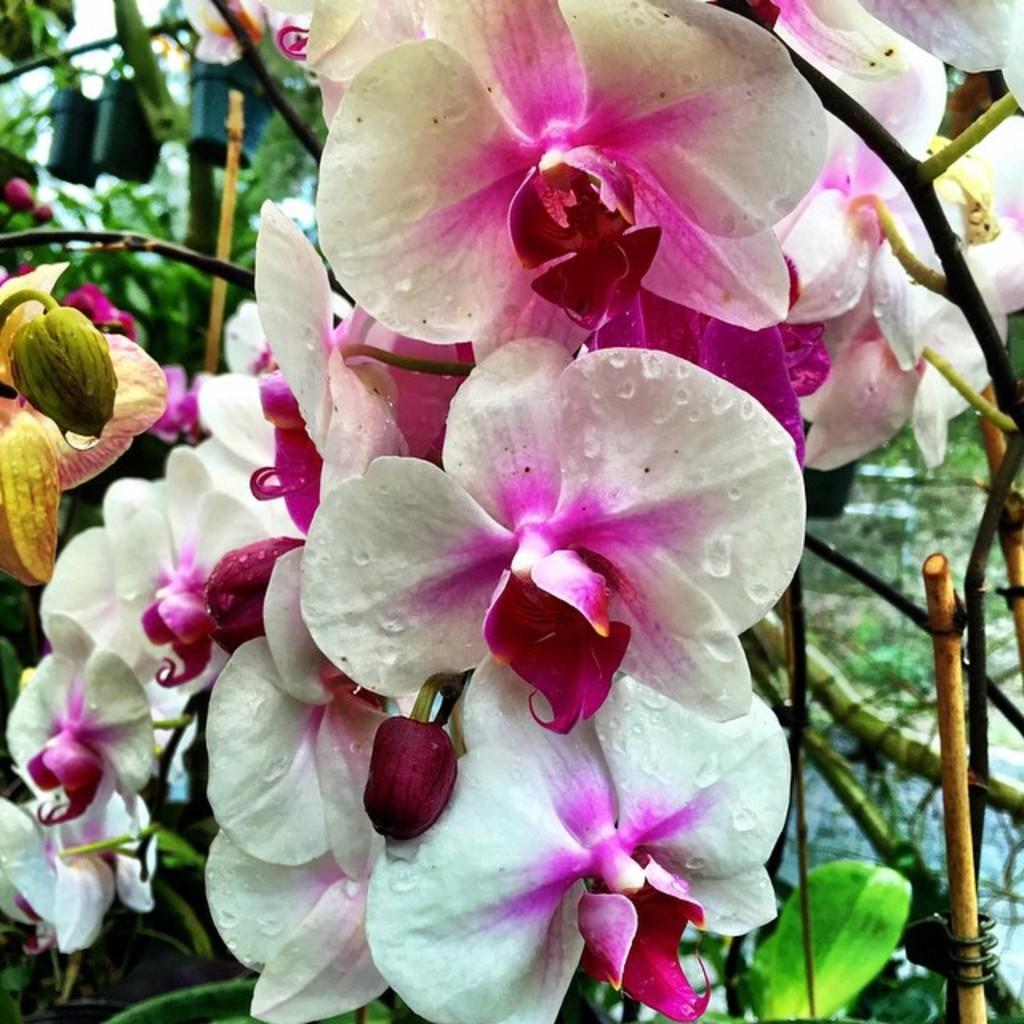What type of plants are in the image? There are flowers in the image. What colors are the flowers? The flowers are pink and white in color. What can be seen in the background of the image? There are flower pots in the background of the image. What language are the flowers speaking in the image? Flowers do not speak any language, so this question cannot be answered. 